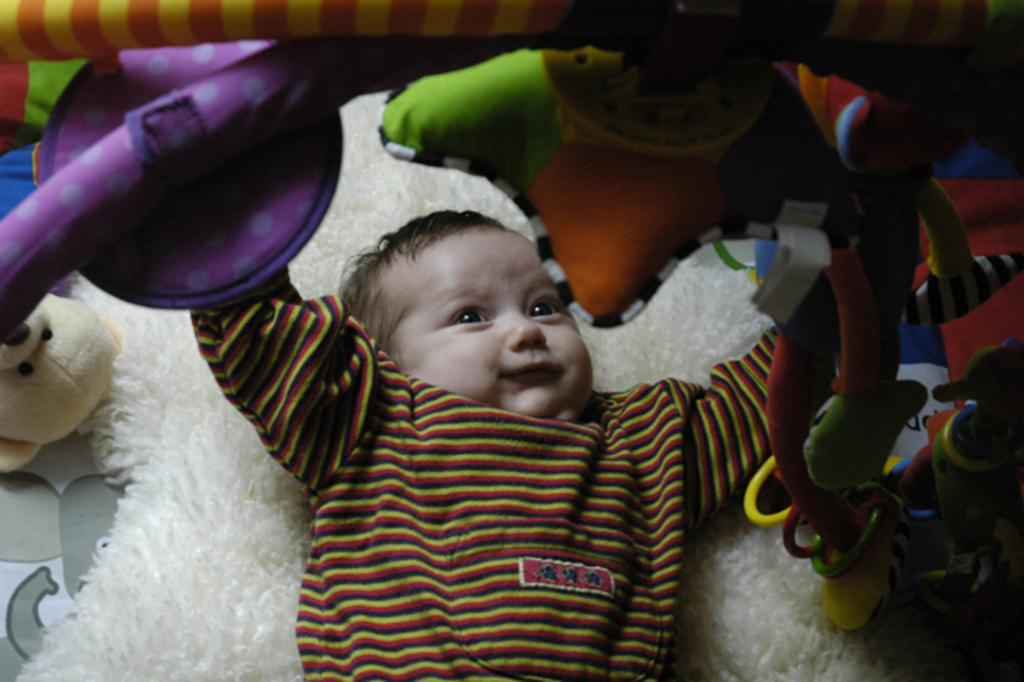What is the main subject of the image? The main subject of the image is a baby lying on a bed. What can be seen hanging from a rod in the image? There are toys hanging from a rod in the image. What type of stuffed animal is present on the left side of the image? There is a teddy bear on the left side of the image. What type of request does the baby make in the image? There is no indication in the image that the baby is making any requests. --- Facts: 1. There is a group of people standing in a circle in the image. 2. Each person is holding a balloon. 3. The balloons are different colors. 4. There is a table with food in the background. Absurd Topics: dance, ocean, instrument Conversation: What are the people in the image doing? The people in the image are standing in a circle. What are the people holding in the image? Each person is holding a balloon. What can be observed about the balloons in the image? The balloons are different colors. What is visible in the background of the image? There is a table with food in the background. Reasoning: Let's think step by step in order to produce the conversation. We start by describing the main action of the people in the image, which is standing in a circle. Then, we mention the balloons they are holding and note the variety of colors. Finally, we describe the table with food in the background, providing additional context about the setting. Absurd Question/Answer: What type of dance is being performed by the people in the image? There is no indication in the image that the people are dancing. --- Facts: 1. There is a car in the image. 2. The car is parked on the side of the road. 3. There are trees in the background. 4. The sky is visible in the image. Absurd Topics: parrot, volcano, costume Conversation: What is the main subject of the image? The main subject of the image is a car. Where is the car located in the image? The car is parked on the side of the road. What can be seen in the background of the image? There are trees in the background. What is visible at the top of the image? The sky is visible in the image. Reasoning: Let's think step by step in order to produce the conversation. We start by identifying the main subject of the image, which is the car. Then, we describe the car's location, noting that it is parked on the side of the road. Next, we mention the trees in the background, providing context about the setting. Finally, we describe the sky visible at the top of the image. Absurd Question/Answer: 